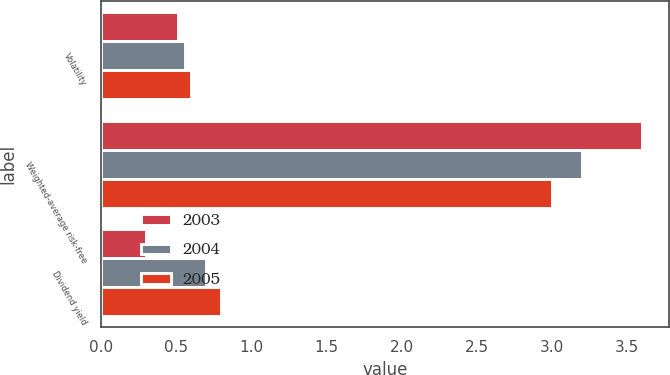Convert chart. <chart><loc_0><loc_0><loc_500><loc_500><stacked_bar_chart><ecel><fcel>Volatility<fcel>Weighted-average risk-free<fcel>Dividend yield<nl><fcel>2003<fcel>0.51<fcel>3.6<fcel>0.3<nl><fcel>2004<fcel>0.56<fcel>3.2<fcel>0.7<nl><fcel>2005<fcel>0.6<fcel>3<fcel>0.8<nl></chart> 